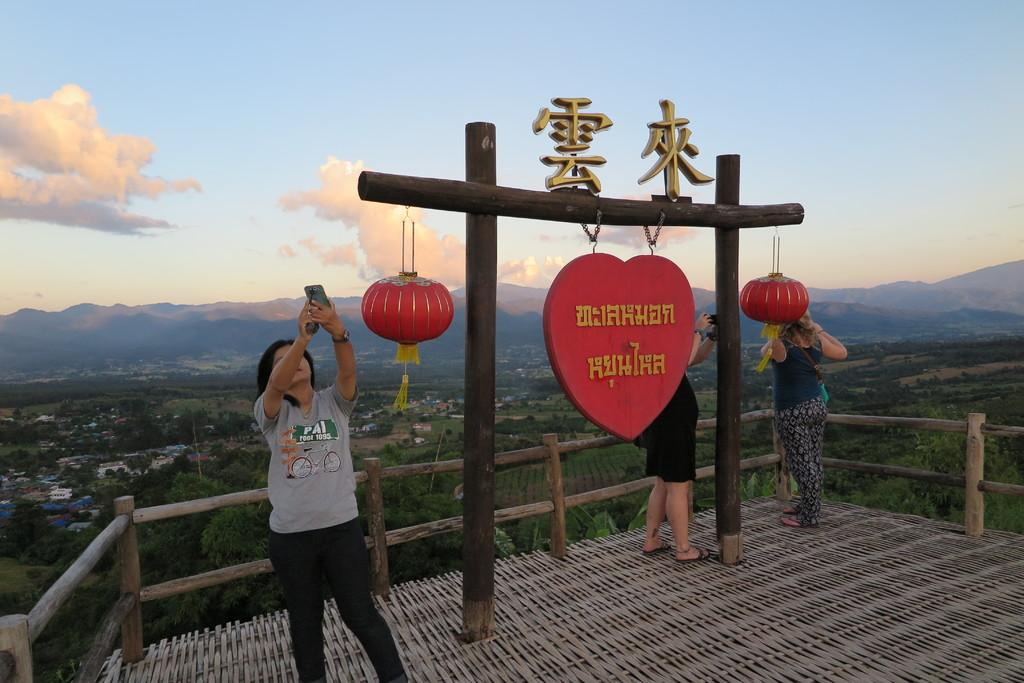How many people are present in the image? There are three people standing in the image. What can be seen in the background of the image? There are trees, houses, and clouds in the sky in the background of the image. What type of worm can be seen crawling on the toothpaste in the image? There is no worm or toothpaste present in the image. 